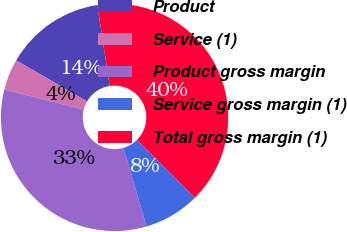Convert chart to OTSL. <chart><loc_0><loc_0><loc_500><loc_500><pie_chart><fcel>Product<fcel>Service (1)<fcel>Product gross margin<fcel>Service gross margin (1)<fcel>Total gross margin (1)<nl><fcel>14.22%<fcel>4.41%<fcel>33.49%<fcel>7.96%<fcel>39.91%<nl></chart> 